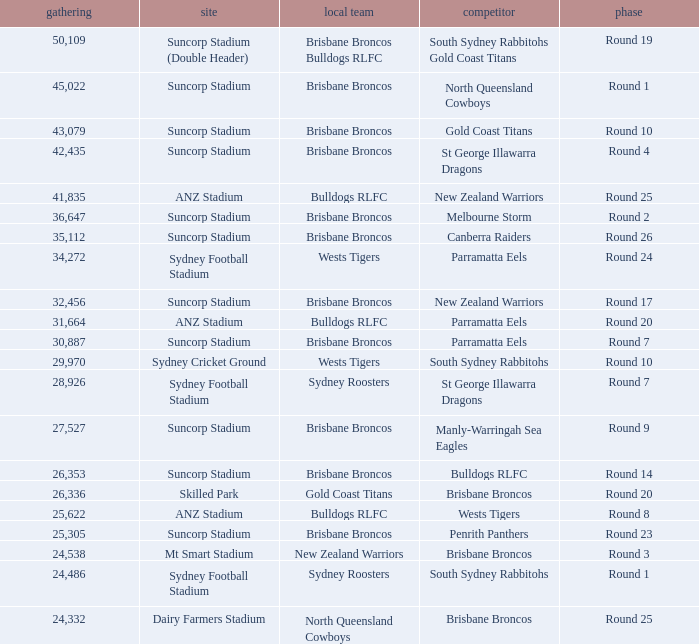What was the attendance at Round 9? 1.0. Can you give me this table as a dict? {'header': ['gathering', 'site', 'local team', 'competitor', 'phase'], 'rows': [['50,109', 'Suncorp Stadium (Double Header)', 'Brisbane Broncos Bulldogs RLFC', 'South Sydney Rabbitohs Gold Coast Titans', 'Round 19'], ['45,022', 'Suncorp Stadium', 'Brisbane Broncos', 'North Queensland Cowboys', 'Round 1'], ['43,079', 'Suncorp Stadium', 'Brisbane Broncos', 'Gold Coast Titans', 'Round 10'], ['42,435', 'Suncorp Stadium', 'Brisbane Broncos', 'St George Illawarra Dragons', 'Round 4'], ['41,835', 'ANZ Stadium', 'Bulldogs RLFC', 'New Zealand Warriors', 'Round 25'], ['36,647', 'Suncorp Stadium', 'Brisbane Broncos', 'Melbourne Storm', 'Round 2'], ['35,112', 'Suncorp Stadium', 'Brisbane Broncos', 'Canberra Raiders', 'Round 26'], ['34,272', 'Sydney Football Stadium', 'Wests Tigers', 'Parramatta Eels', 'Round 24'], ['32,456', 'Suncorp Stadium', 'Brisbane Broncos', 'New Zealand Warriors', 'Round 17'], ['31,664', 'ANZ Stadium', 'Bulldogs RLFC', 'Parramatta Eels', 'Round 20'], ['30,887', 'Suncorp Stadium', 'Brisbane Broncos', 'Parramatta Eels', 'Round 7'], ['29,970', 'Sydney Cricket Ground', 'Wests Tigers', 'South Sydney Rabbitohs', 'Round 10'], ['28,926', 'Sydney Football Stadium', 'Sydney Roosters', 'St George Illawarra Dragons', 'Round 7'], ['27,527', 'Suncorp Stadium', 'Brisbane Broncos', 'Manly-Warringah Sea Eagles', 'Round 9'], ['26,353', 'Suncorp Stadium', 'Brisbane Broncos', 'Bulldogs RLFC', 'Round 14'], ['26,336', 'Skilled Park', 'Gold Coast Titans', 'Brisbane Broncos', 'Round 20'], ['25,622', 'ANZ Stadium', 'Bulldogs RLFC', 'Wests Tigers', 'Round 8'], ['25,305', 'Suncorp Stadium', 'Brisbane Broncos', 'Penrith Panthers', 'Round 23'], ['24,538', 'Mt Smart Stadium', 'New Zealand Warriors', 'Brisbane Broncos', 'Round 3'], ['24,486', 'Sydney Football Stadium', 'Sydney Roosters', 'South Sydney Rabbitohs', 'Round 1'], ['24,332', 'Dairy Farmers Stadium', 'North Queensland Cowboys', 'Brisbane Broncos', 'Round 25']]} 